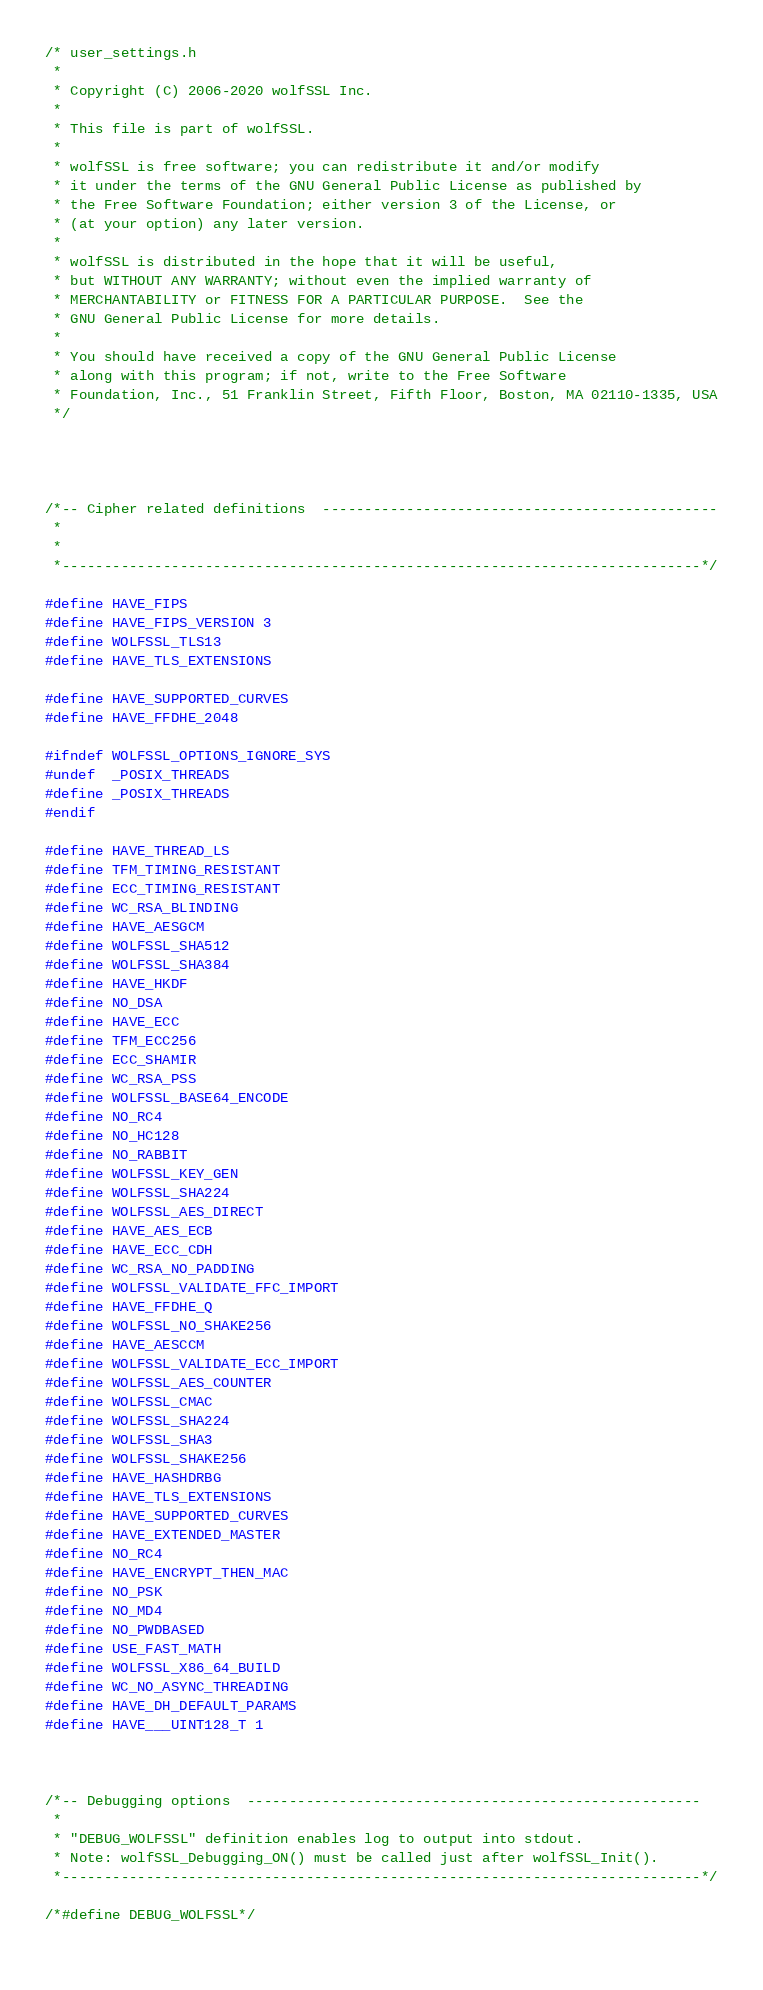Convert code to text. <code><loc_0><loc_0><loc_500><loc_500><_C_>/* user_settings.h
 *
 * Copyright (C) 2006-2020 wolfSSL Inc.
 *
 * This file is part of wolfSSL.
 *
 * wolfSSL is free software; you can redistribute it and/or modify
 * it under the terms of the GNU General Public License as published by
 * the Free Software Foundation; either version 3 of the License, or
 * (at your option) any later version.
 *
 * wolfSSL is distributed in the hope that it will be useful,
 * but WITHOUT ANY WARRANTY; without even the implied warranty of
 * MERCHANTABILITY or FITNESS FOR A PARTICULAR PURPOSE.  See the
 * GNU General Public License for more details.
 *
 * You should have received a copy of the GNU General Public License
 * along with this program; if not, write to the Free Software
 * Foundation, Inc., 51 Franklin Street, Fifth Floor, Boston, MA 02110-1335, USA
 */




/*-- Cipher related definitions  -----------------------------------------------
 *
 *
 *----------------------------------------------------------------------------*/

#define HAVE_FIPS
#define HAVE_FIPS_VERSION 3
#define WOLFSSL_TLS13
#define HAVE_TLS_EXTENSIONS

#define HAVE_SUPPORTED_CURVES
#define HAVE_FFDHE_2048

#ifndef WOLFSSL_OPTIONS_IGNORE_SYS
#undef  _POSIX_THREADS
#define _POSIX_THREADS
#endif

#define HAVE_THREAD_LS
#define TFM_TIMING_RESISTANT
#define ECC_TIMING_RESISTANT
#define WC_RSA_BLINDING
#define HAVE_AESGCM
#define WOLFSSL_SHA512
#define WOLFSSL_SHA384
#define HAVE_HKDF
#define NO_DSA
#define HAVE_ECC
#define TFM_ECC256
#define ECC_SHAMIR
#define WC_RSA_PSS
#define WOLFSSL_BASE64_ENCODE
#define NO_RC4
#define NO_HC128
#define NO_RABBIT
#define WOLFSSL_KEY_GEN
#define WOLFSSL_SHA224
#define WOLFSSL_AES_DIRECT
#define HAVE_AES_ECB
#define HAVE_ECC_CDH
#define WC_RSA_NO_PADDING
#define WOLFSSL_VALIDATE_FFC_IMPORT
#define HAVE_FFDHE_Q
#define WOLFSSL_NO_SHAKE256
#define HAVE_AESCCM
#define WOLFSSL_VALIDATE_ECC_IMPORT
#define WOLFSSL_AES_COUNTER
#define WOLFSSL_CMAC
#define WOLFSSL_SHA224
#define WOLFSSL_SHA3
#define WOLFSSL_SHAKE256
#define HAVE_HASHDRBG
#define HAVE_TLS_EXTENSIONS
#define HAVE_SUPPORTED_CURVES
#define HAVE_EXTENDED_MASTER
#define NO_RC4
#define HAVE_ENCRYPT_THEN_MAC
#define NO_PSK
#define NO_MD4
#define NO_PWDBASED
#define USE_FAST_MATH
#define WOLFSSL_X86_64_BUILD
#define WC_NO_ASYNC_THREADING
#define HAVE_DH_DEFAULT_PARAMS
#define HAVE___UINT128_T 1



/*-- Debugging options  ------------------------------------------------------
 *
 * "DEBUG_WOLFSSL" definition enables log to output into stdout.
 * Note: wolfSSL_Debugging_ON() must be called just after wolfSSL_Init().
 *----------------------------------------------------------------------------*/

/*#define DEBUG_WOLFSSL*/
	

</code> 